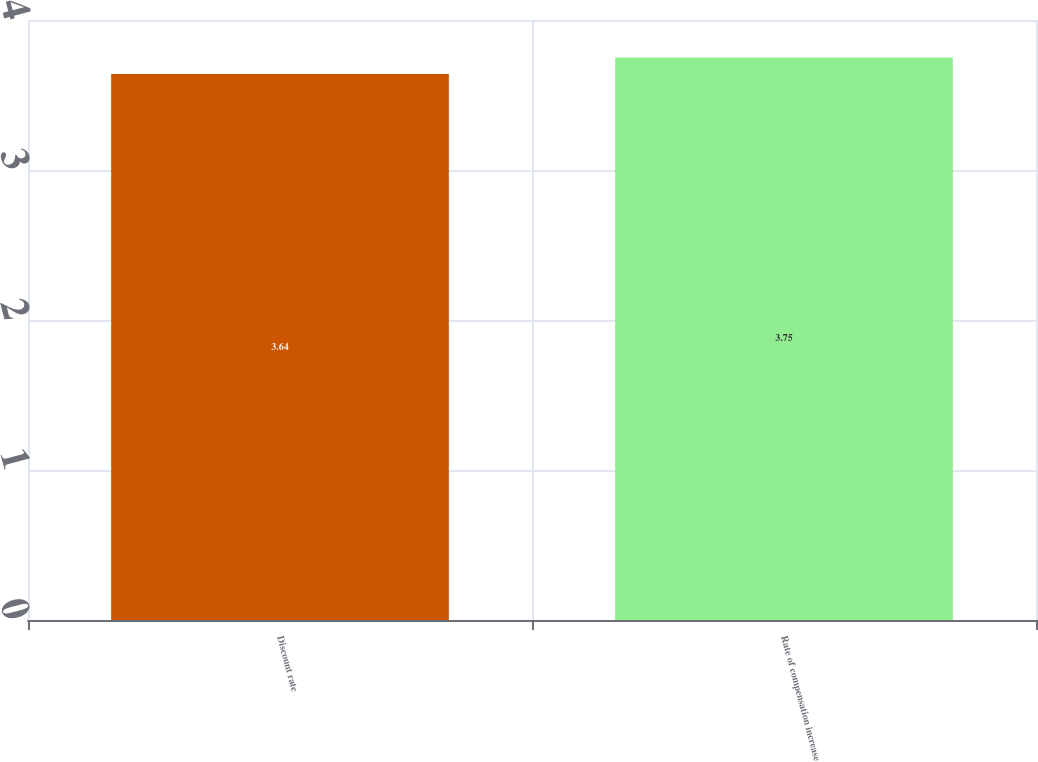<chart> <loc_0><loc_0><loc_500><loc_500><bar_chart><fcel>Discount rate<fcel>Rate of compensation increase<nl><fcel>3.64<fcel>3.75<nl></chart> 